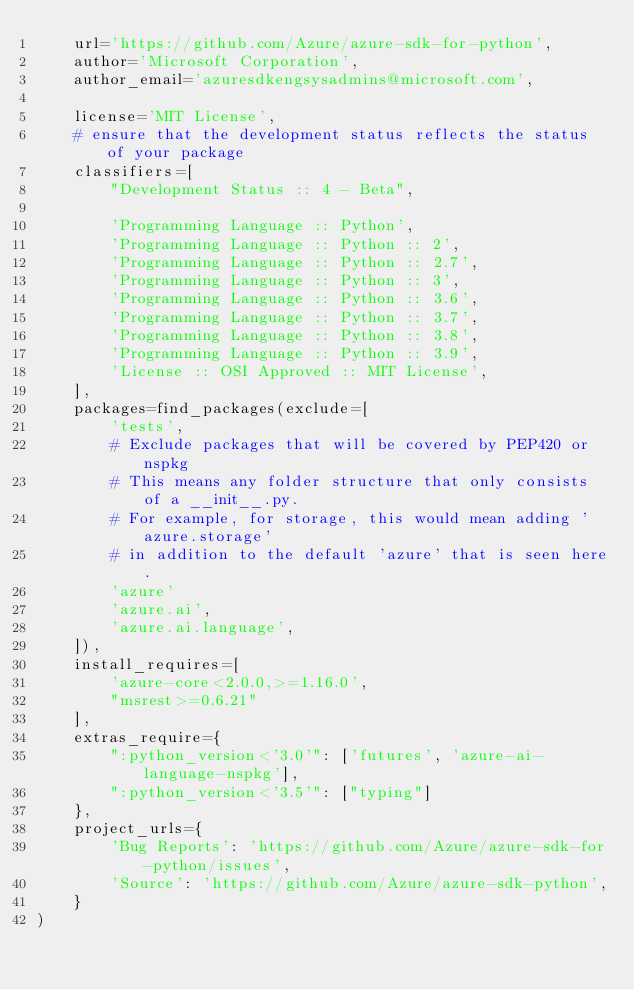<code> <loc_0><loc_0><loc_500><loc_500><_Python_>    url='https://github.com/Azure/azure-sdk-for-python',
    author='Microsoft Corporation',
    author_email='azuresdkengsysadmins@microsoft.com',

    license='MIT License',
    # ensure that the development status reflects the status of your package
    classifiers=[
        "Development Status :: 4 - Beta",

        'Programming Language :: Python',
        'Programming Language :: Python :: 2',
        'Programming Language :: Python :: 2.7',
        'Programming Language :: Python :: 3',
        'Programming Language :: Python :: 3.6',
        'Programming Language :: Python :: 3.7',
        'Programming Language :: Python :: 3.8',
        'Programming Language :: Python :: 3.9',
        'License :: OSI Approved :: MIT License',
    ],
    packages=find_packages(exclude=[
        'tests',
        # Exclude packages that will be covered by PEP420 or nspkg
        # This means any folder structure that only consists of a __init__.py. 
        # For example, for storage, this would mean adding 'azure.storage' 
        # in addition to the default 'azure' that is seen here.
        'azure'
        'azure.ai',
        'azure.ai.language',
    ]),
    install_requires=[
        'azure-core<2.0.0,>=1.16.0',
        "msrest>=0.6.21"
    ],
    extras_require={
        ":python_version<'3.0'": ['futures', 'azure-ai-language-nspkg'],
        ":python_version<'3.5'": ["typing"]
    },
    project_urls={
        'Bug Reports': 'https://github.com/Azure/azure-sdk-for-python/issues',
        'Source': 'https://github.com/Azure/azure-sdk-python',
    }
)
</code> 